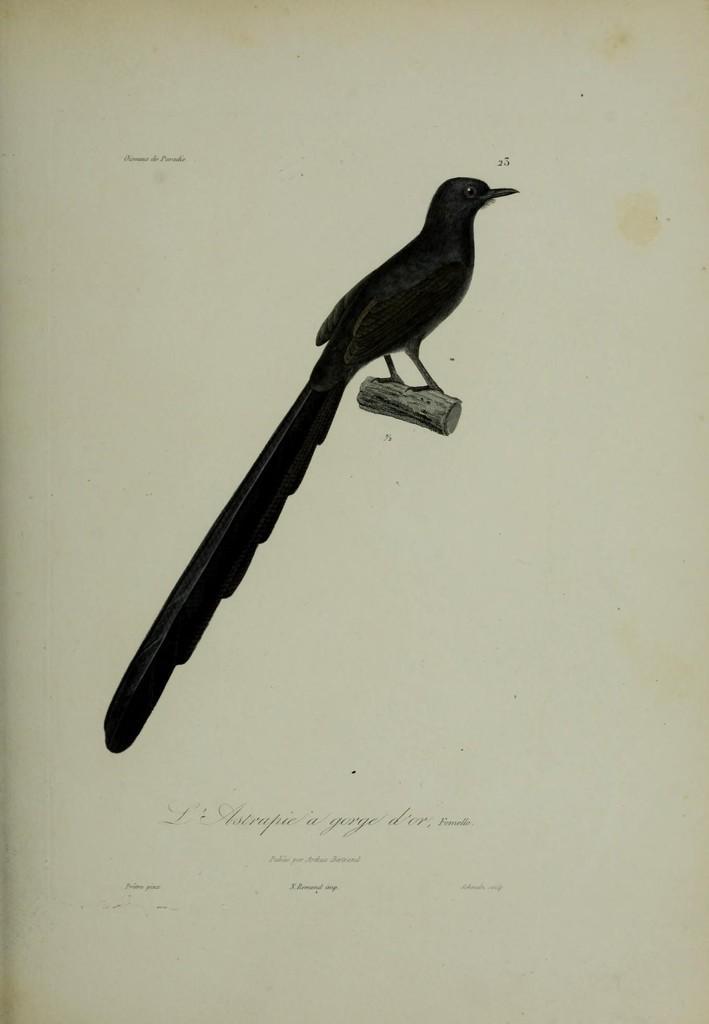Please provide a concise description of this image. In this picture we can see a bird on a wooden log and some text on the page. 